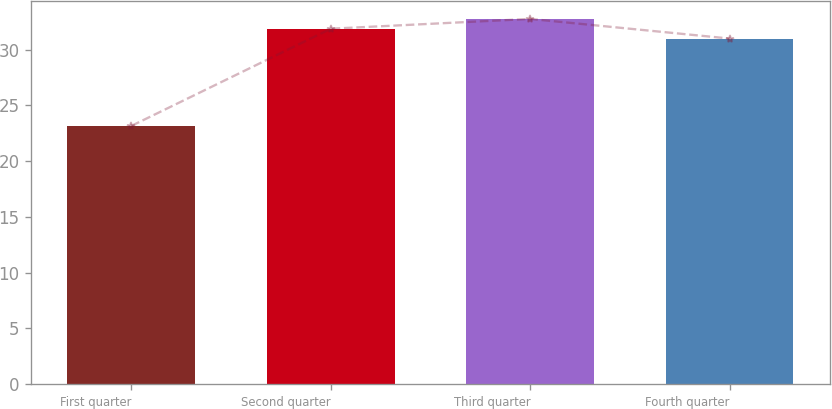Convert chart to OTSL. <chart><loc_0><loc_0><loc_500><loc_500><bar_chart><fcel>First quarter<fcel>Second quarter<fcel>Third quarter<fcel>Fourth quarter<nl><fcel>23.16<fcel>31.87<fcel>32.75<fcel>30.99<nl></chart> 